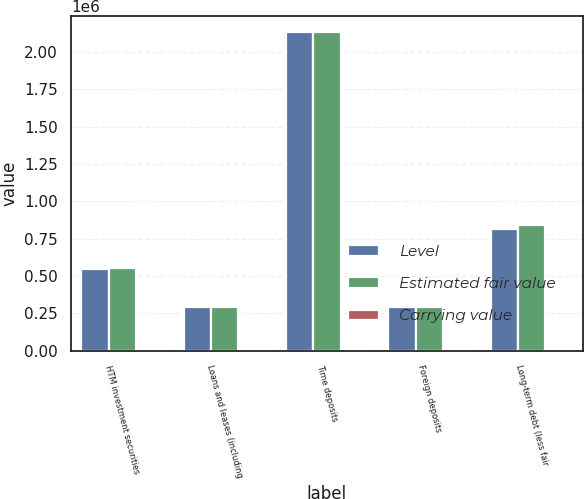Convert chart to OTSL. <chart><loc_0><loc_0><loc_500><loc_500><stacked_bar_chart><ecel><fcel>HTM investment securities<fcel>Loans and leases (including<fcel>Time deposits<fcel>Foreign deposits<fcel>Long-term debt (less fair<nl><fcel>Level<fcel>545648<fcel>294391<fcel>2.13068e+06<fcel>294391<fcel>817348<nl><fcel>Estimated fair value<fcel>552088<fcel>294391<fcel>2.12974e+06<fcel>294321<fcel>838796<nl><fcel>Carrying value<fcel>2<fcel>3<fcel>2<fcel>2<fcel>2<nl></chart> 